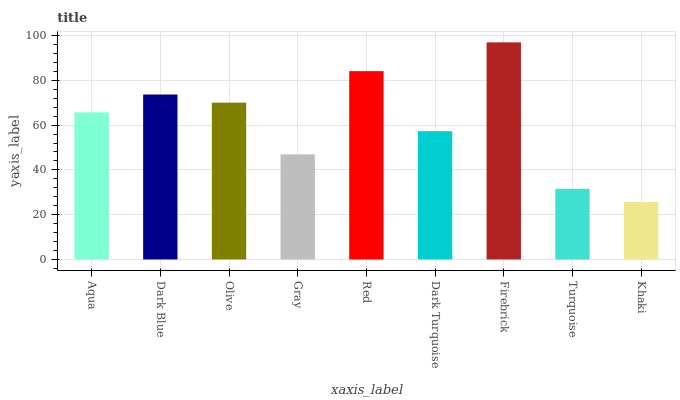Is Khaki the minimum?
Answer yes or no. Yes. Is Firebrick the maximum?
Answer yes or no. Yes. Is Dark Blue the minimum?
Answer yes or no. No. Is Dark Blue the maximum?
Answer yes or no. No. Is Dark Blue greater than Aqua?
Answer yes or no. Yes. Is Aqua less than Dark Blue?
Answer yes or no. Yes. Is Aqua greater than Dark Blue?
Answer yes or no. No. Is Dark Blue less than Aqua?
Answer yes or no. No. Is Aqua the high median?
Answer yes or no. Yes. Is Aqua the low median?
Answer yes or no. Yes. Is Firebrick the high median?
Answer yes or no. No. Is Dark Turquoise the low median?
Answer yes or no. No. 